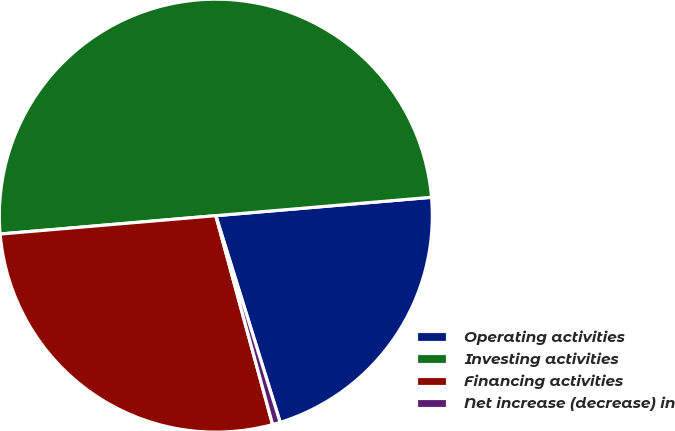Convert chart to OTSL. <chart><loc_0><loc_0><loc_500><loc_500><pie_chart><fcel>Operating activities<fcel>Investing activities<fcel>Financing activities<fcel>Net increase (decrease) in<nl><fcel>21.55%<fcel>50.0%<fcel>27.87%<fcel>0.58%<nl></chart> 